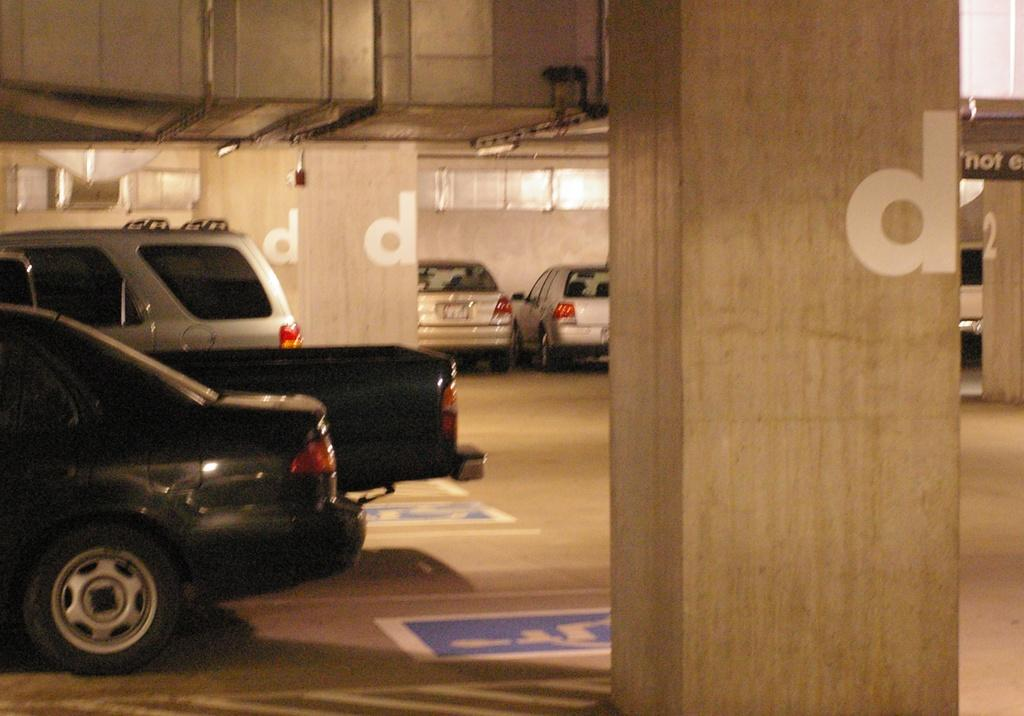What can be seen on the left side of the image? There are vehicles on the left side of the image. What is located in the middle of the image? There are pillars in the middle of the image, and the area resembles a cellar. What type of popcorn can be seen in the harmony of the error in the image? There is no popcorn, harmony, or error present in the image. 